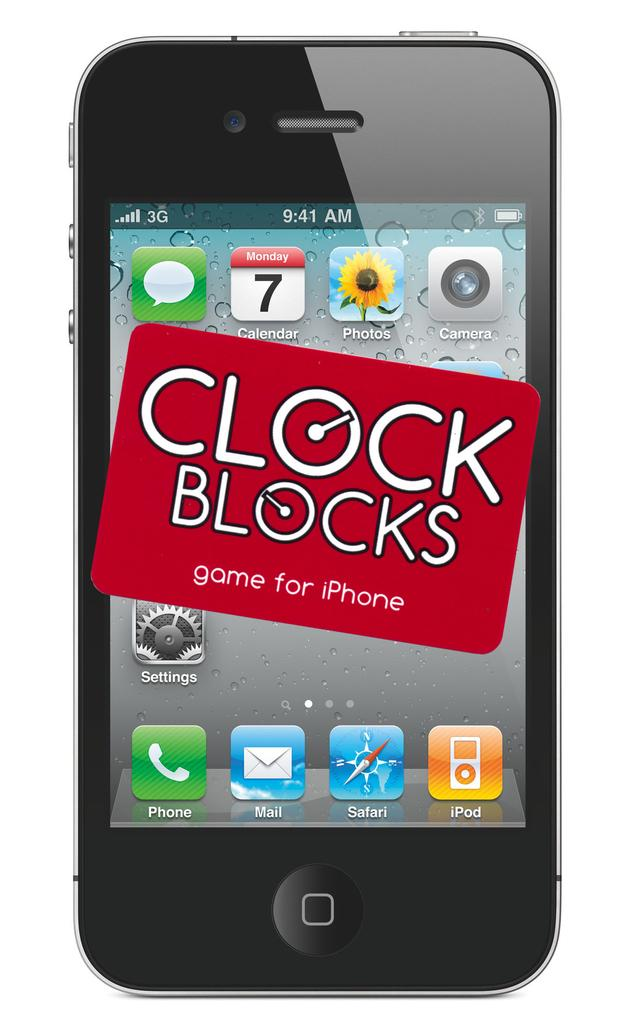<image>
Relay a brief, clear account of the picture shown. black iphone with a red square on front for clock blocks game 